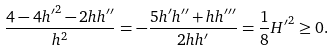Convert formula to latex. <formula><loc_0><loc_0><loc_500><loc_500>\frac { 4 - 4 { h ^ { \prime } } ^ { 2 } - 2 h h ^ { \prime \prime } } { h ^ { 2 } } = - \frac { 5 h ^ { \prime } h ^ { \prime \prime } + h h ^ { \prime \prime \prime } } { 2 h h ^ { \prime } } = \frac { 1 } { 8 } { H ^ { \prime } } ^ { 2 } \geq 0 .</formula> 